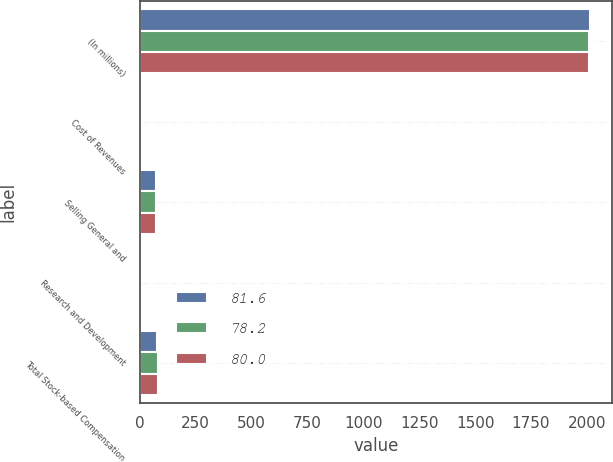<chart> <loc_0><loc_0><loc_500><loc_500><stacked_bar_chart><ecel><fcel>(In millions)<fcel>Cost of Revenues<fcel>Selling General and<fcel>Research and Development<fcel>Total Stock-based Compensation<nl><fcel>81.6<fcel>2012<fcel>5.4<fcel>70.7<fcel>2.1<fcel>78.2<nl><fcel>78.2<fcel>2011<fcel>5.7<fcel>72.4<fcel>1.9<fcel>80<nl><fcel>80<fcel>2010<fcel>5.8<fcel>74<fcel>1.8<fcel>81.6<nl></chart> 